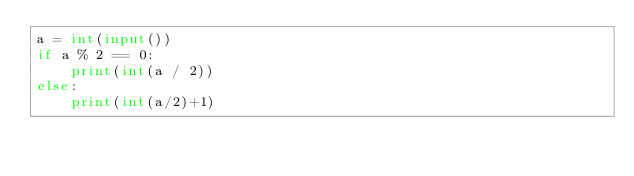Convert code to text. <code><loc_0><loc_0><loc_500><loc_500><_Python_>a = int(input())
if a % 2 == 0:
    print(int(a / 2))
else:
    print(int(a/2)+1)
</code> 